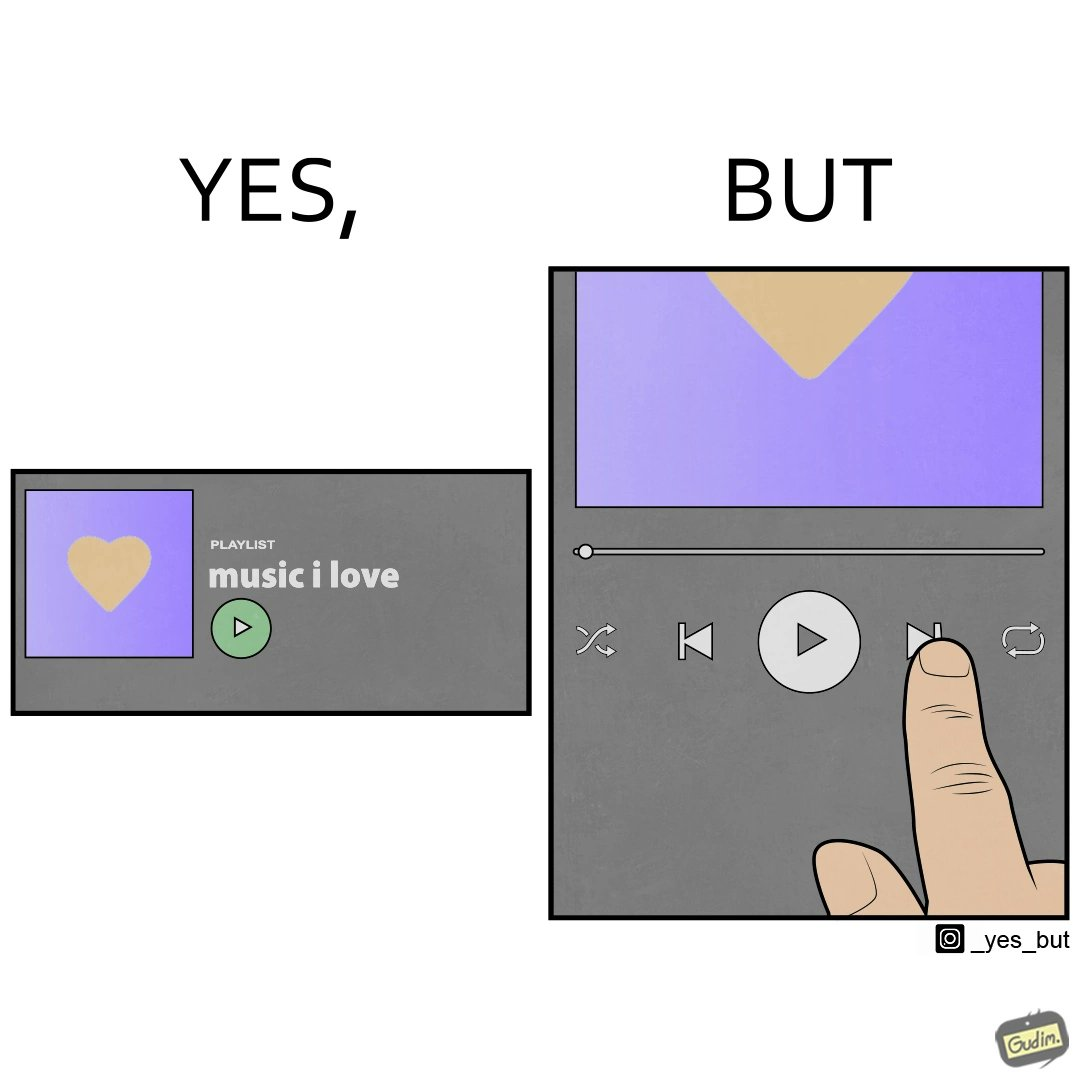Is there satirical content in this image? Yes, this image is satirical. 